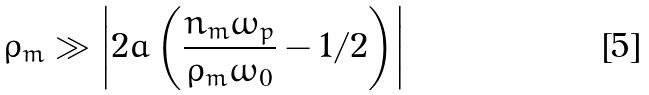Convert formula to latex. <formula><loc_0><loc_0><loc_500><loc_500>\rho _ { m } \gg \left | 2 a \left ( \frac { n _ { m } \omega _ { p } } { \rho _ { m } \omega _ { 0 } } - 1 / 2 \right ) \right |</formula> 